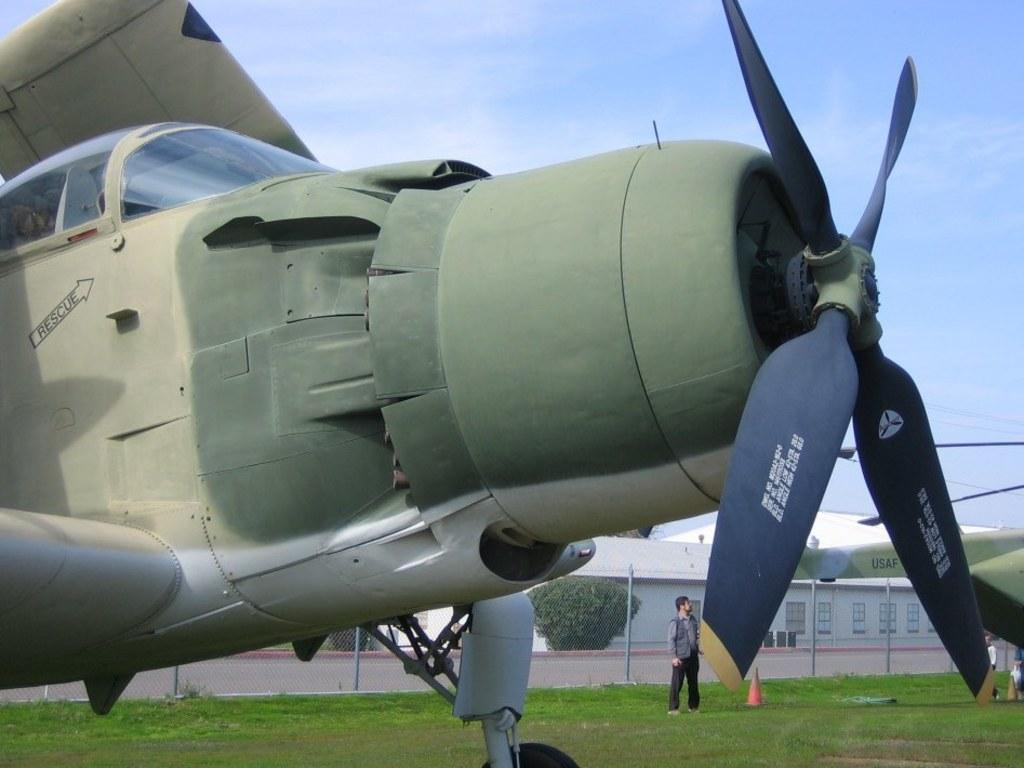<image>
Provide a brief description of the given image. the front propellers of an old plane with the words RESCUE near the cockpit 